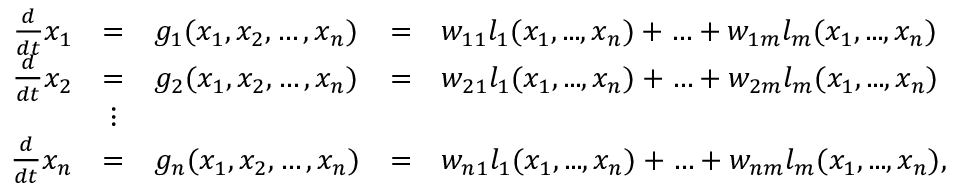Convert formula to latex. <formula><loc_0><loc_0><loc_500><loc_500>\begin{array} { r c l c l } { \frac { d } { d t } x _ { 1 } } & { = } & { g _ { 1 } ( x _ { 1 } , x _ { 2 } , \dots , x _ { n } ) } & { = } & { w _ { 1 1 } l _ { 1 } ( x _ { 1 } , \dots , x _ { n } ) + \dots + w _ { 1 m } l _ { m } ( x _ { 1 } , \dots , x _ { n } ) } \\ { \frac { d } { d t } x _ { 2 } } & { = } & { g _ { 2 } ( x _ { 1 } , x _ { 2 } , \dots , x _ { n } ) } & { = } & { w _ { 2 1 } l _ { 1 } ( x _ { 1 } , \dots , x _ { n } ) + \dots + w _ { 2 m } l _ { m } ( x _ { 1 } , \dots , x _ { n } ) } \\ & { \vdots } & \\ { \frac { d } { d t } x _ { n } } & { = } & { g _ { n } ( x _ { 1 } , x _ { 2 } , \dots , x _ { n } ) } & { = } & { w _ { n 1 } l _ { 1 } ( x _ { 1 } , \dots , x _ { n } ) + \dots + w _ { n m } l _ { m } ( x _ { 1 } , \dots , x _ { n } ) , } \end{array}</formula> 